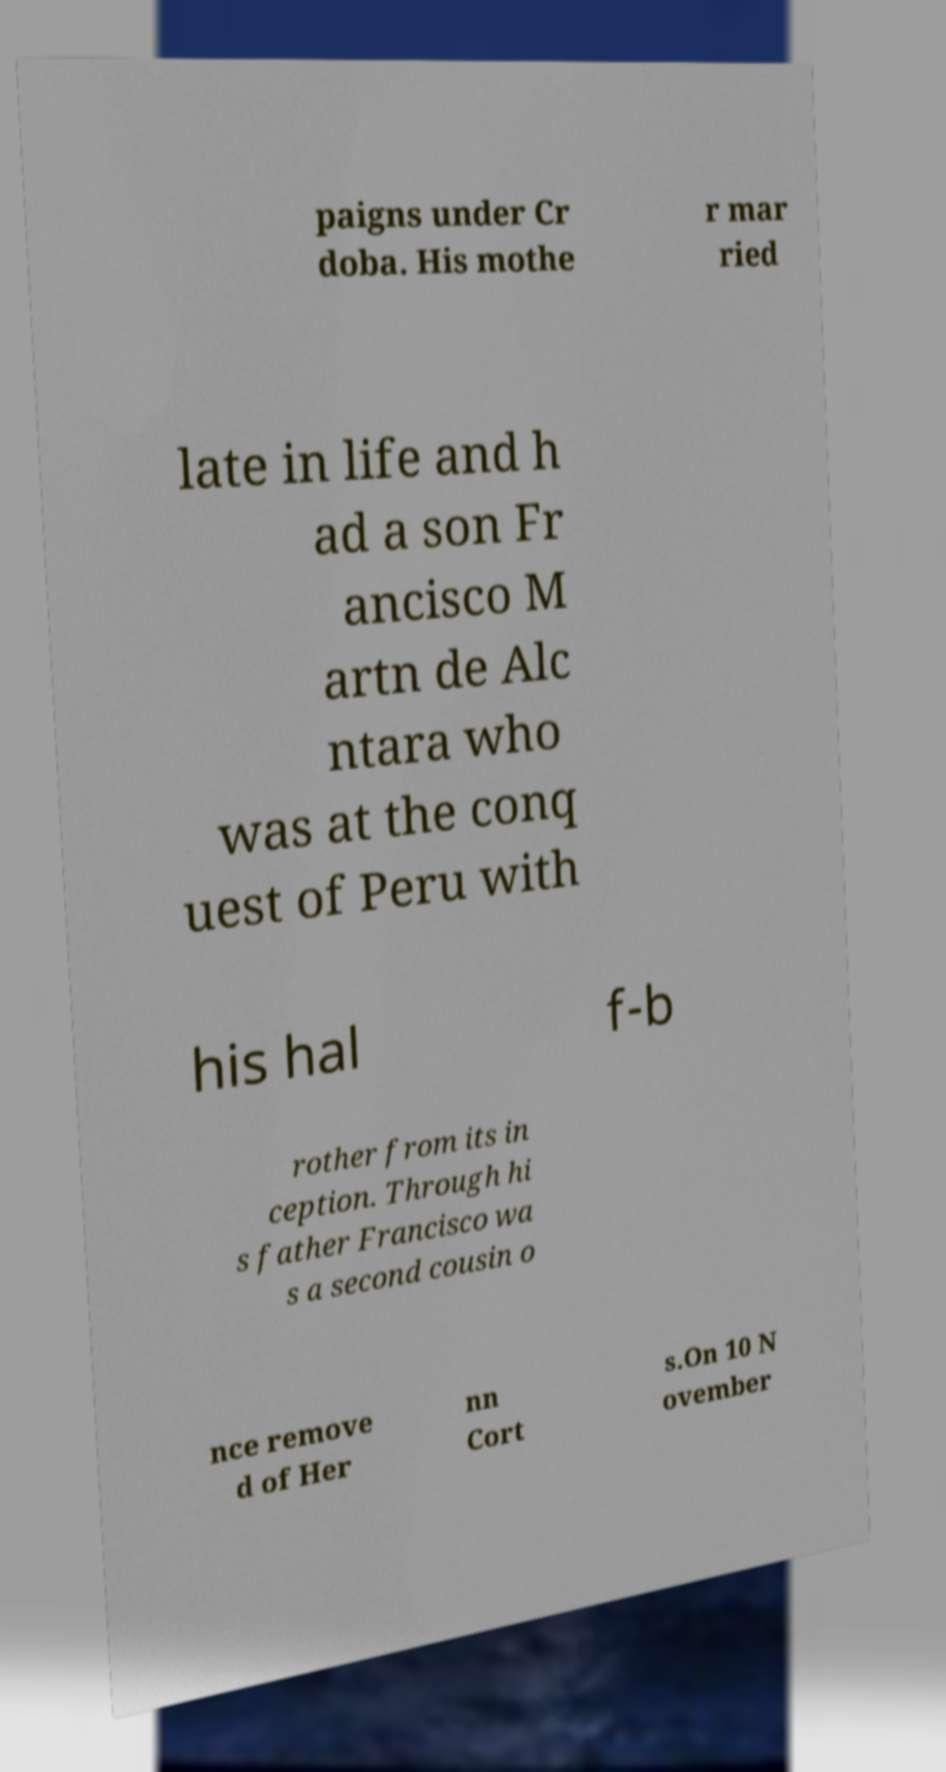For documentation purposes, I need the text within this image transcribed. Could you provide that? paigns under Cr doba. His mothe r mar ried late in life and h ad a son Fr ancisco M artn de Alc ntara who was at the conq uest of Peru with his hal f-b rother from its in ception. Through hi s father Francisco wa s a second cousin o nce remove d of Her nn Cort s.On 10 N ovember 